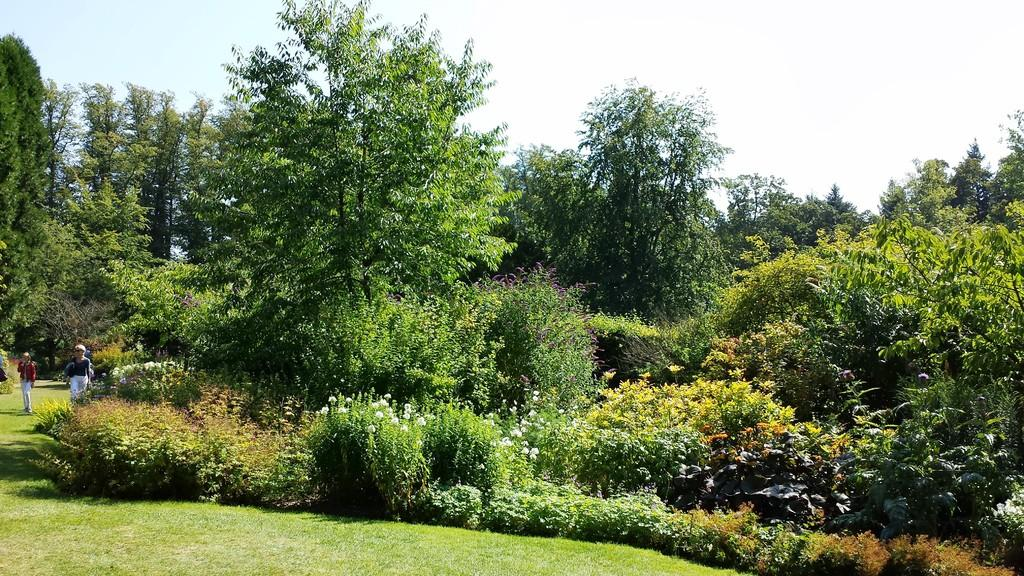What type of natural environment is visible in the image? There is grass in the image, which suggests a natural environment. What are the persons in the image doing? There are persons walking in the image. What can be seen in the background of the image? There are trees in the background of the image. What is the condition of the sky in the image? The sky is visible at the top of the image and appears to be clear. Where is the mailbox located in the image? There is no mailbox present in the image. What type of rifle can be seen in the hands of the persons walking in the image? There are no rifles present in the image; the persons are simply walking. 